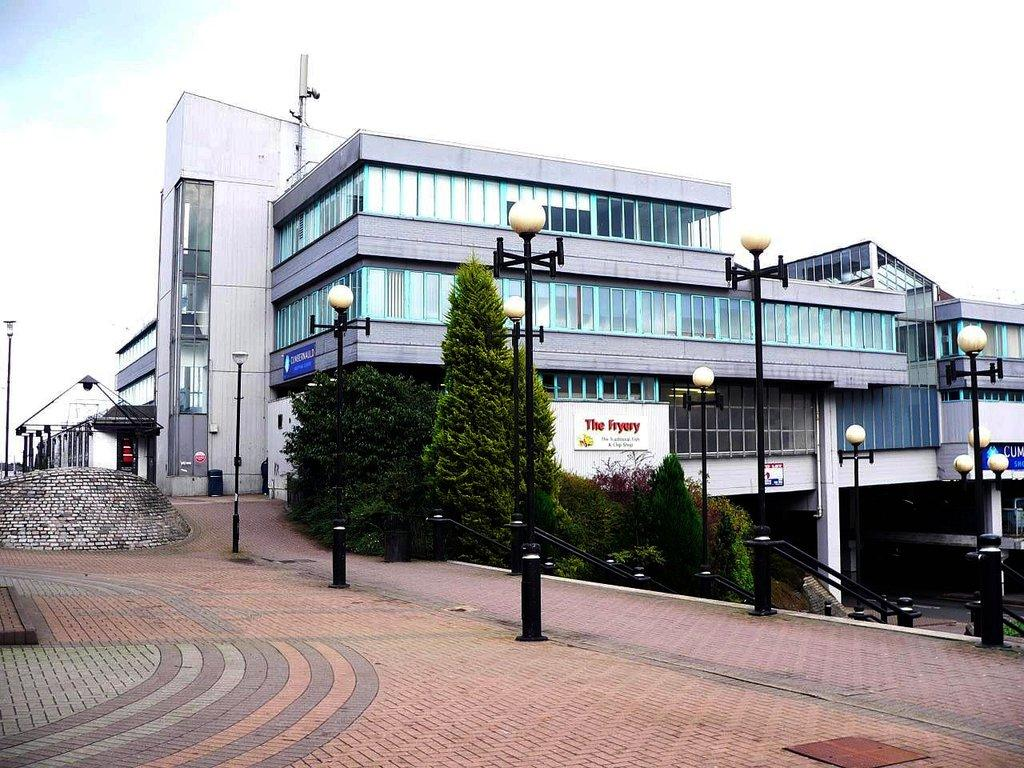What type of structures can be seen in the image? There are buildings in the image. What other objects are present in the image? There are poles, trees, and a railing in the image. What is the color of the sky in the image? The sky is white in color. Where is the brick wall located in the image? The brick wall is present on the left side of the image. What shape are the dolls in the image? There are no dolls present in the image. What advice does the father give in the image? There is no father present in the image, so it is not possible to determine any advice given. 